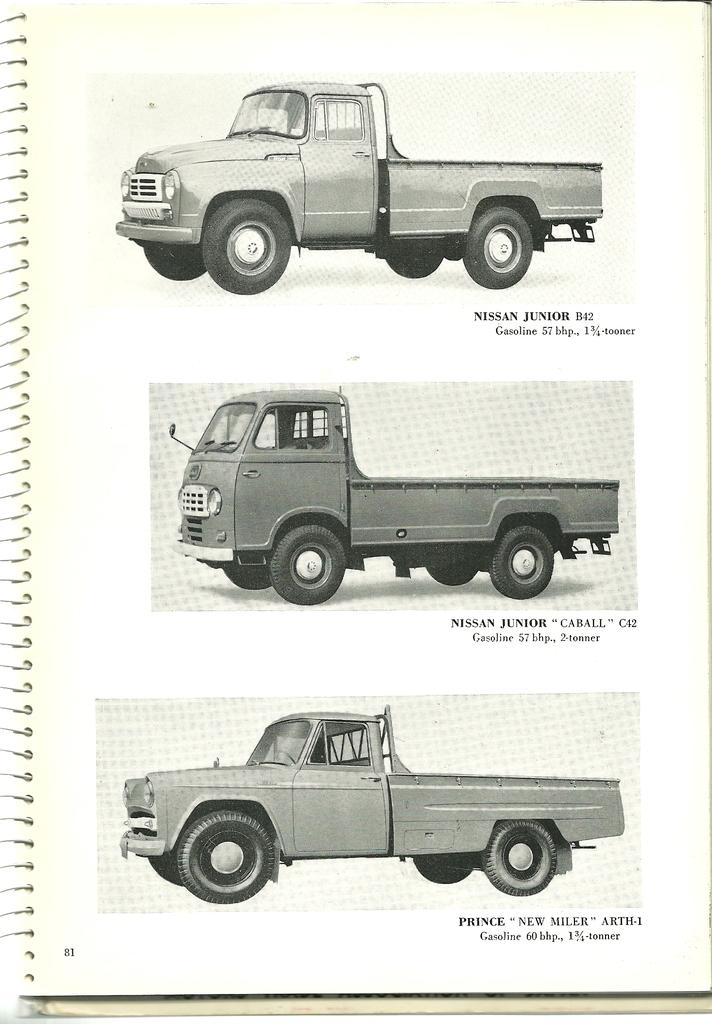What is the main subject of the image? There is a book in the image. What type of content is in the book? The book contains pictures of vehicles. Is there any text in the book? Yes, there is text in the book. What is the color of the background in the image? The background of the image is white in color. What type of mitten is being used to turn the pages of the book in the image? There is no mitten present in the image, and the book is not being interacted with in any way. What is the voice of the rat in the image saying about the vehicles? There is no rat present in the image, and therefore no voice or commentary can be attributed to it. 